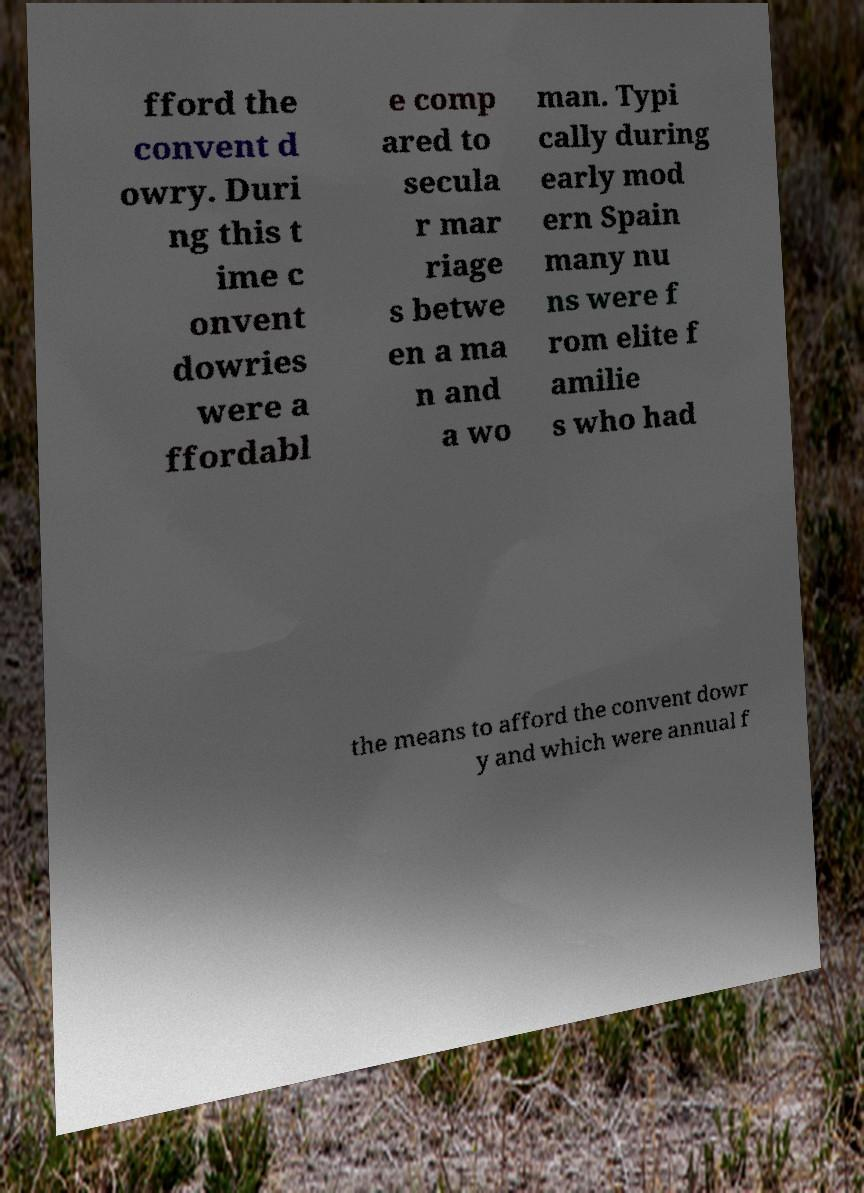What messages or text are displayed in this image? I need them in a readable, typed format. fford the convent d owry. Duri ng this t ime c onvent dowries were a ffordabl e comp ared to secula r mar riage s betwe en a ma n and a wo man. Typi cally during early mod ern Spain many nu ns were f rom elite f amilie s who had the means to afford the convent dowr y and which were annual f 